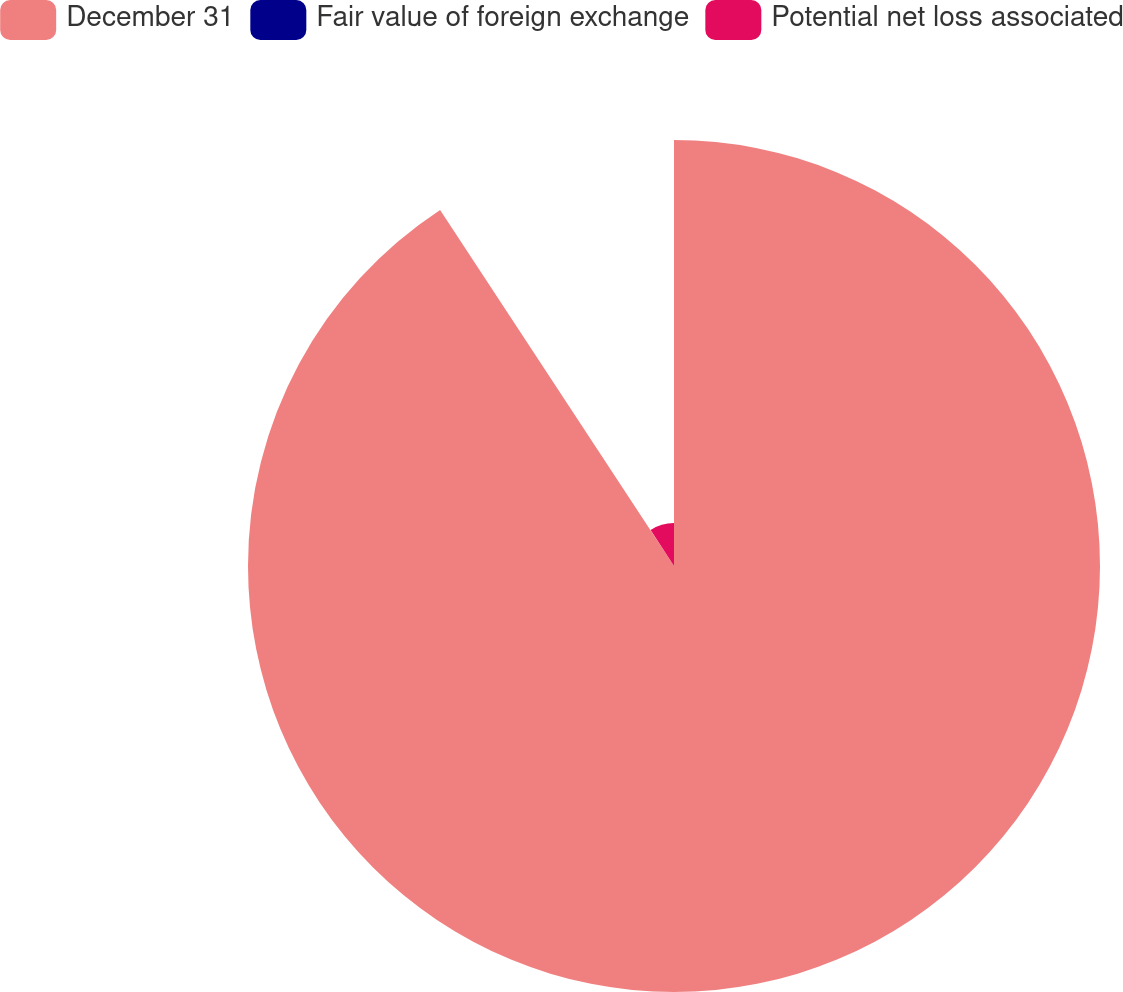Convert chart to OTSL. <chart><loc_0><loc_0><loc_500><loc_500><pie_chart><fcel>December 31<fcel>Fair value of foreign exchange<fcel>Potential net loss associated<nl><fcel>90.75%<fcel>0.09%<fcel>9.16%<nl></chart> 